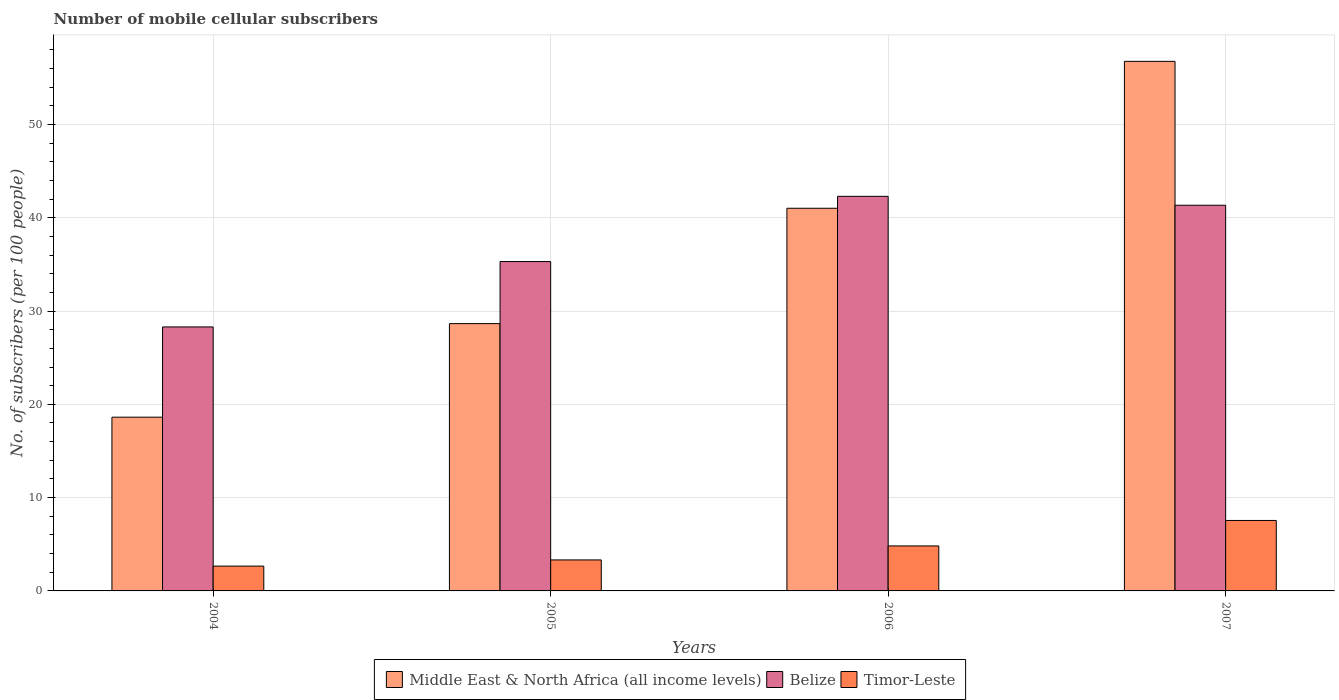How many different coloured bars are there?
Give a very brief answer. 3. How many groups of bars are there?
Make the answer very short. 4. What is the label of the 4th group of bars from the left?
Your answer should be compact. 2007. What is the number of mobile cellular subscribers in Middle East & North Africa (all income levels) in 2004?
Provide a short and direct response. 18.62. Across all years, what is the maximum number of mobile cellular subscribers in Belize?
Make the answer very short. 42.3. Across all years, what is the minimum number of mobile cellular subscribers in Belize?
Ensure brevity in your answer.  28.3. In which year was the number of mobile cellular subscribers in Middle East & North Africa (all income levels) minimum?
Your answer should be very brief. 2004. What is the total number of mobile cellular subscribers in Middle East & North Africa (all income levels) in the graph?
Make the answer very short. 145.06. What is the difference between the number of mobile cellular subscribers in Timor-Leste in 2004 and that in 2005?
Ensure brevity in your answer.  -0.66. What is the difference between the number of mobile cellular subscribers in Middle East & North Africa (all income levels) in 2007 and the number of mobile cellular subscribers in Timor-Leste in 2005?
Make the answer very short. 53.44. What is the average number of mobile cellular subscribers in Belize per year?
Offer a terse response. 36.81. In the year 2007, what is the difference between the number of mobile cellular subscribers in Belize and number of mobile cellular subscribers in Timor-Leste?
Provide a succinct answer. 33.79. In how many years, is the number of mobile cellular subscribers in Timor-Leste greater than 24?
Give a very brief answer. 0. What is the ratio of the number of mobile cellular subscribers in Belize in 2005 to that in 2006?
Give a very brief answer. 0.83. Is the difference between the number of mobile cellular subscribers in Belize in 2005 and 2006 greater than the difference between the number of mobile cellular subscribers in Timor-Leste in 2005 and 2006?
Offer a terse response. No. What is the difference between the highest and the second highest number of mobile cellular subscribers in Belize?
Make the answer very short. 0.96. What is the difference between the highest and the lowest number of mobile cellular subscribers in Timor-Leste?
Your answer should be compact. 4.89. What does the 3rd bar from the left in 2004 represents?
Ensure brevity in your answer.  Timor-Leste. What does the 1st bar from the right in 2005 represents?
Your answer should be very brief. Timor-Leste. What is the difference between two consecutive major ticks on the Y-axis?
Keep it short and to the point. 10. Does the graph contain any zero values?
Keep it short and to the point. No. Does the graph contain grids?
Your answer should be very brief. Yes. Where does the legend appear in the graph?
Offer a very short reply. Bottom center. What is the title of the graph?
Keep it short and to the point. Number of mobile cellular subscribers. What is the label or title of the X-axis?
Provide a short and direct response. Years. What is the label or title of the Y-axis?
Offer a very short reply. No. of subscribers (per 100 people). What is the No. of subscribers (per 100 people) of Middle East & North Africa (all income levels) in 2004?
Your response must be concise. 18.62. What is the No. of subscribers (per 100 people) in Belize in 2004?
Your answer should be compact. 28.3. What is the No. of subscribers (per 100 people) in Timor-Leste in 2004?
Your response must be concise. 2.66. What is the No. of subscribers (per 100 people) in Middle East & North Africa (all income levels) in 2005?
Give a very brief answer. 28.65. What is the No. of subscribers (per 100 people) in Belize in 2005?
Keep it short and to the point. 35.3. What is the No. of subscribers (per 100 people) in Timor-Leste in 2005?
Provide a short and direct response. 3.32. What is the No. of subscribers (per 100 people) in Middle East & North Africa (all income levels) in 2006?
Keep it short and to the point. 41.02. What is the No. of subscribers (per 100 people) of Belize in 2006?
Your answer should be compact. 42.3. What is the No. of subscribers (per 100 people) of Timor-Leste in 2006?
Make the answer very short. 4.82. What is the No. of subscribers (per 100 people) in Middle East & North Africa (all income levels) in 2007?
Your response must be concise. 56.76. What is the No. of subscribers (per 100 people) of Belize in 2007?
Ensure brevity in your answer.  41.34. What is the No. of subscribers (per 100 people) in Timor-Leste in 2007?
Offer a terse response. 7.55. Across all years, what is the maximum No. of subscribers (per 100 people) in Middle East & North Africa (all income levels)?
Your answer should be compact. 56.76. Across all years, what is the maximum No. of subscribers (per 100 people) in Belize?
Offer a terse response. 42.3. Across all years, what is the maximum No. of subscribers (per 100 people) in Timor-Leste?
Offer a terse response. 7.55. Across all years, what is the minimum No. of subscribers (per 100 people) of Middle East & North Africa (all income levels)?
Offer a very short reply. 18.62. Across all years, what is the minimum No. of subscribers (per 100 people) of Belize?
Your answer should be compact. 28.3. Across all years, what is the minimum No. of subscribers (per 100 people) in Timor-Leste?
Make the answer very short. 2.66. What is the total No. of subscribers (per 100 people) of Middle East & North Africa (all income levels) in the graph?
Your answer should be very brief. 145.06. What is the total No. of subscribers (per 100 people) in Belize in the graph?
Make the answer very short. 147.24. What is the total No. of subscribers (per 100 people) in Timor-Leste in the graph?
Provide a succinct answer. 18.36. What is the difference between the No. of subscribers (per 100 people) of Middle East & North Africa (all income levels) in 2004 and that in 2005?
Offer a terse response. -10.03. What is the difference between the No. of subscribers (per 100 people) of Belize in 2004 and that in 2005?
Give a very brief answer. -7.01. What is the difference between the No. of subscribers (per 100 people) in Timor-Leste in 2004 and that in 2005?
Ensure brevity in your answer.  -0.66. What is the difference between the No. of subscribers (per 100 people) of Middle East & North Africa (all income levels) in 2004 and that in 2006?
Your answer should be compact. -22.39. What is the difference between the No. of subscribers (per 100 people) in Belize in 2004 and that in 2006?
Your answer should be compact. -14. What is the difference between the No. of subscribers (per 100 people) of Timor-Leste in 2004 and that in 2006?
Offer a terse response. -2.16. What is the difference between the No. of subscribers (per 100 people) in Middle East & North Africa (all income levels) in 2004 and that in 2007?
Your answer should be compact. -38.14. What is the difference between the No. of subscribers (per 100 people) of Belize in 2004 and that in 2007?
Your answer should be very brief. -13.04. What is the difference between the No. of subscribers (per 100 people) in Timor-Leste in 2004 and that in 2007?
Your answer should be compact. -4.89. What is the difference between the No. of subscribers (per 100 people) of Middle East & North Africa (all income levels) in 2005 and that in 2006?
Your response must be concise. -12.37. What is the difference between the No. of subscribers (per 100 people) of Belize in 2005 and that in 2006?
Your answer should be compact. -6.99. What is the difference between the No. of subscribers (per 100 people) in Timor-Leste in 2005 and that in 2006?
Provide a short and direct response. -1.5. What is the difference between the No. of subscribers (per 100 people) in Middle East & North Africa (all income levels) in 2005 and that in 2007?
Keep it short and to the point. -28.11. What is the difference between the No. of subscribers (per 100 people) in Belize in 2005 and that in 2007?
Your answer should be compact. -6.04. What is the difference between the No. of subscribers (per 100 people) in Timor-Leste in 2005 and that in 2007?
Offer a very short reply. -4.23. What is the difference between the No. of subscribers (per 100 people) of Middle East & North Africa (all income levels) in 2006 and that in 2007?
Your answer should be compact. -15.75. What is the difference between the No. of subscribers (per 100 people) of Belize in 2006 and that in 2007?
Provide a short and direct response. 0.96. What is the difference between the No. of subscribers (per 100 people) in Timor-Leste in 2006 and that in 2007?
Provide a short and direct response. -2.73. What is the difference between the No. of subscribers (per 100 people) of Middle East & North Africa (all income levels) in 2004 and the No. of subscribers (per 100 people) of Belize in 2005?
Your answer should be very brief. -16.68. What is the difference between the No. of subscribers (per 100 people) of Middle East & North Africa (all income levels) in 2004 and the No. of subscribers (per 100 people) of Timor-Leste in 2005?
Offer a terse response. 15.3. What is the difference between the No. of subscribers (per 100 people) of Belize in 2004 and the No. of subscribers (per 100 people) of Timor-Leste in 2005?
Provide a short and direct response. 24.98. What is the difference between the No. of subscribers (per 100 people) of Middle East & North Africa (all income levels) in 2004 and the No. of subscribers (per 100 people) of Belize in 2006?
Your answer should be compact. -23.67. What is the difference between the No. of subscribers (per 100 people) in Belize in 2004 and the No. of subscribers (per 100 people) in Timor-Leste in 2006?
Ensure brevity in your answer.  23.47. What is the difference between the No. of subscribers (per 100 people) of Middle East & North Africa (all income levels) in 2004 and the No. of subscribers (per 100 people) of Belize in 2007?
Ensure brevity in your answer.  -22.72. What is the difference between the No. of subscribers (per 100 people) of Middle East & North Africa (all income levels) in 2004 and the No. of subscribers (per 100 people) of Timor-Leste in 2007?
Provide a succinct answer. 11.07. What is the difference between the No. of subscribers (per 100 people) of Belize in 2004 and the No. of subscribers (per 100 people) of Timor-Leste in 2007?
Ensure brevity in your answer.  20.75. What is the difference between the No. of subscribers (per 100 people) of Middle East & North Africa (all income levels) in 2005 and the No. of subscribers (per 100 people) of Belize in 2006?
Provide a short and direct response. -13.64. What is the difference between the No. of subscribers (per 100 people) of Middle East & North Africa (all income levels) in 2005 and the No. of subscribers (per 100 people) of Timor-Leste in 2006?
Provide a short and direct response. 23.83. What is the difference between the No. of subscribers (per 100 people) of Belize in 2005 and the No. of subscribers (per 100 people) of Timor-Leste in 2006?
Ensure brevity in your answer.  30.48. What is the difference between the No. of subscribers (per 100 people) of Middle East & North Africa (all income levels) in 2005 and the No. of subscribers (per 100 people) of Belize in 2007?
Provide a short and direct response. -12.69. What is the difference between the No. of subscribers (per 100 people) in Middle East & North Africa (all income levels) in 2005 and the No. of subscribers (per 100 people) in Timor-Leste in 2007?
Offer a terse response. 21.1. What is the difference between the No. of subscribers (per 100 people) of Belize in 2005 and the No. of subscribers (per 100 people) of Timor-Leste in 2007?
Provide a succinct answer. 27.75. What is the difference between the No. of subscribers (per 100 people) of Middle East & North Africa (all income levels) in 2006 and the No. of subscribers (per 100 people) of Belize in 2007?
Ensure brevity in your answer.  -0.32. What is the difference between the No. of subscribers (per 100 people) of Middle East & North Africa (all income levels) in 2006 and the No. of subscribers (per 100 people) of Timor-Leste in 2007?
Your answer should be compact. 33.47. What is the difference between the No. of subscribers (per 100 people) of Belize in 2006 and the No. of subscribers (per 100 people) of Timor-Leste in 2007?
Offer a terse response. 34.74. What is the average No. of subscribers (per 100 people) in Middle East & North Africa (all income levels) per year?
Give a very brief answer. 36.26. What is the average No. of subscribers (per 100 people) in Belize per year?
Ensure brevity in your answer.  36.81. What is the average No. of subscribers (per 100 people) of Timor-Leste per year?
Provide a short and direct response. 4.59. In the year 2004, what is the difference between the No. of subscribers (per 100 people) in Middle East & North Africa (all income levels) and No. of subscribers (per 100 people) in Belize?
Keep it short and to the point. -9.67. In the year 2004, what is the difference between the No. of subscribers (per 100 people) of Middle East & North Africa (all income levels) and No. of subscribers (per 100 people) of Timor-Leste?
Provide a succinct answer. 15.96. In the year 2004, what is the difference between the No. of subscribers (per 100 people) of Belize and No. of subscribers (per 100 people) of Timor-Leste?
Your answer should be compact. 25.64. In the year 2005, what is the difference between the No. of subscribers (per 100 people) in Middle East & North Africa (all income levels) and No. of subscribers (per 100 people) in Belize?
Offer a very short reply. -6.65. In the year 2005, what is the difference between the No. of subscribers (per 100 people) of Middle East & North Africa (all income levels) and No. of subscribers (per 100 people) of Timor-Leste?
Provide a succinct answer. 25.33. In the year 2005, what is the difference between the No. of subscribers (per 100 people) of Belize and No. of subscribers (per 100 people) of Timor-Leste?
Your response must be concise. 31.98. In the year 2006, what is the difference between the No. of subscribers (per 100 people) of Middle East & North Africa (all income levels) and No. of subscribers (per 100 people) of Belize?
Your answer should be compact. -1.28. In the year 2006, what is the difference between the No. of subscribers (per 100 people) of Middle East & North Africa (all income levels) and No. of subscribers (per 100 people) of Timor-Leste?
Your answer should be compact. 36.19. In the year 2006, what is the difference between the No. of subscribers (per 100 people) of Belize and No. of subscribers (per 100 people) of Timor-Leste?
Your response must be concise. 37.47. In the year 2007, what is the difference between the No. of subscribers (per 100 people) of Middle East & North Africa (all income levels) and No. of subscribers (per 100 people) of Belize?
Make the answer very short. 15.42. In the year 2007, what is the difference between the No. of subscribers (per 100 people) in Middle East & North Africa (all income levels) and No. of subscribers (per 100 people) in Timor-Leste?
Your answer should be very brief. 49.21. In the year 2007, what is the difference between the No. of subscribers (per 100 people) of Belize and No. of subscribers (per 100 people) of Timor-Leste?
Give a very brief answer. 33.79. What is the ratio of the No. of subscribers (per 100 people) in Middle East & North Africa (all income levels) in 2004 to that in 2005?
Give a very brief answer. 0.65. What is the ratio of the No. of subscribers (per 100 people) in Belize in 2004 to that in 2005?
Provide a succinct answer. 0.8. What is the ratio of the No. of subscribers (per 100 people) in Timor-Leste in 2004 to that in 2005?
Offer a terse response. 0.8. What is the ratio of the No. of subscribers (per 100 people) in Middle East & North Africa (all income levels) in 2004 to that in 2006?
Your answer should be very brief. 0.45. What is the ratio of the No. of subscribers (per 100 people) of Belize in 2004 to that in 2006?
Your response must be concise. 0.67. What is the ratio of the No. of subscribers (per 100 people) of Timor-Leste in 2004 to that in 2006?
Provide a succinct answer. 0.55. What is the ratio of the No. of subscribers (per 100 people) of Middle East & North Africa (all income levels) in 2004 to that in 2007?
Provide a short and direct response. 0.33. What is the ratio of the No. of subscribers (per 100 people) of Belize in 2004 to that in 2007?
Offer a very short reply. 0.68. What is the ratio of the No. of subscribers (per 100 people) in Timor-Leste in 2004 to that in 2007?
Your answer should be compact. 0.35. What is the ratio of the No. of subscribers (per 100 people) in Middle East & North Africa (all income levels) in 2005 to that in 2006?
Provide a succinct answer. 0.7. What is the ratio of the No. of subscribers (per 100 people) of Belize in 2005 to that in 2006?
Offer a terse response. 0.83. What is the ratio of the No. of subscribers (per 100 people) of Timor-Leste in 2005 to that in 2006?
Offer a very short reply. 0.69. What is the ratio of the No. of subscribers (per 100 people) in Middle East & North Africa (all income levels) in 2005 to that in 2007?
Your response must be concise. 0.5. What is the ratio of the No. of subscribers (per 100 people) in Belize in 2005 to that in 2007?
Offer a very short reply. 0.85. What is the ratio of the No. of subscribers (per 100 people) in Timor-Leste in 2005 to that in 2007?
Your answer should be compact. 0.44. What is the ratio of the No. of subscribers (per 100 people) of Middle East & North Africa (all income levels) in 2006 to that in 2007?
Your answer should be compact. 0.72. What is the ratio of the No. of subscribers (per 100 people) of Belize in 2006 to that in 2007?
Give a very brief answer. 1.02. What is the ratio of the No. of subscribers (per 100 people) in Timor-Leste in 2006 to that in 2007?
Your answer should be compact. 0.64. What is the difference between the highest and the second highest No. of subscribers (per 100 people) in Middle East & North Africa (all income levels)?
Provide a succinct answer. 15.75. What is the difference between the highest and the second highest No. of subscribers (per 100 people) of Belize?
Give a very brief answer. 0.96. What is the difference between the highest and the second highest No. of subscribers (per 100 people) of Timor-Leste?
Ensure brevity in your answer.  2.73. What is the difference between the highest and the lowest No. of subscribers (per 100 people) of Middle East & North Africa (all income levels)?
Give a very brief answer. 38.14. What is the difference between the highest and the lowest No. of subscribers (per 100 people) in Belize?
Your answer should be very brief. 14. What is the difference between the highest and the lowest No. of subscribers (per 100 people) in Timor-Leste?
Offer a very short reply. 4.89. 